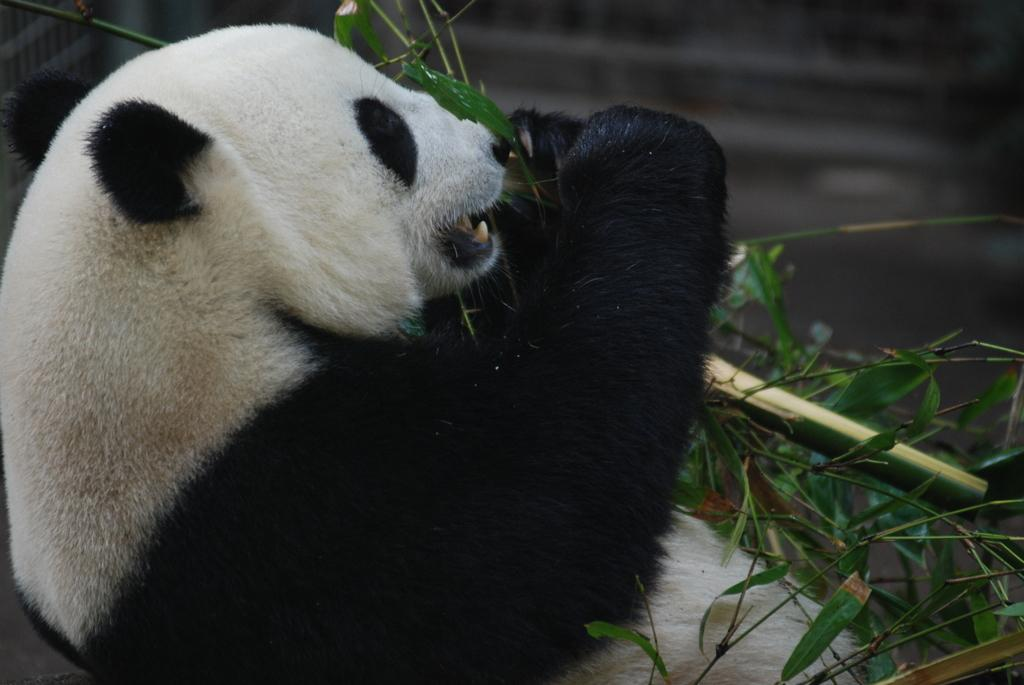What animal is the main subject of the image? There is a panda in the image. What colors are present on the panda? The panda is in black and white color. What is the panda holding in the image? The panda is holding a plant. What color is the background of the image? The background of the image is black. How many feathers can be seen on the panda in the image? There are no feathers present on the panda in the image, as pandas are mammals and do not have feathers. 